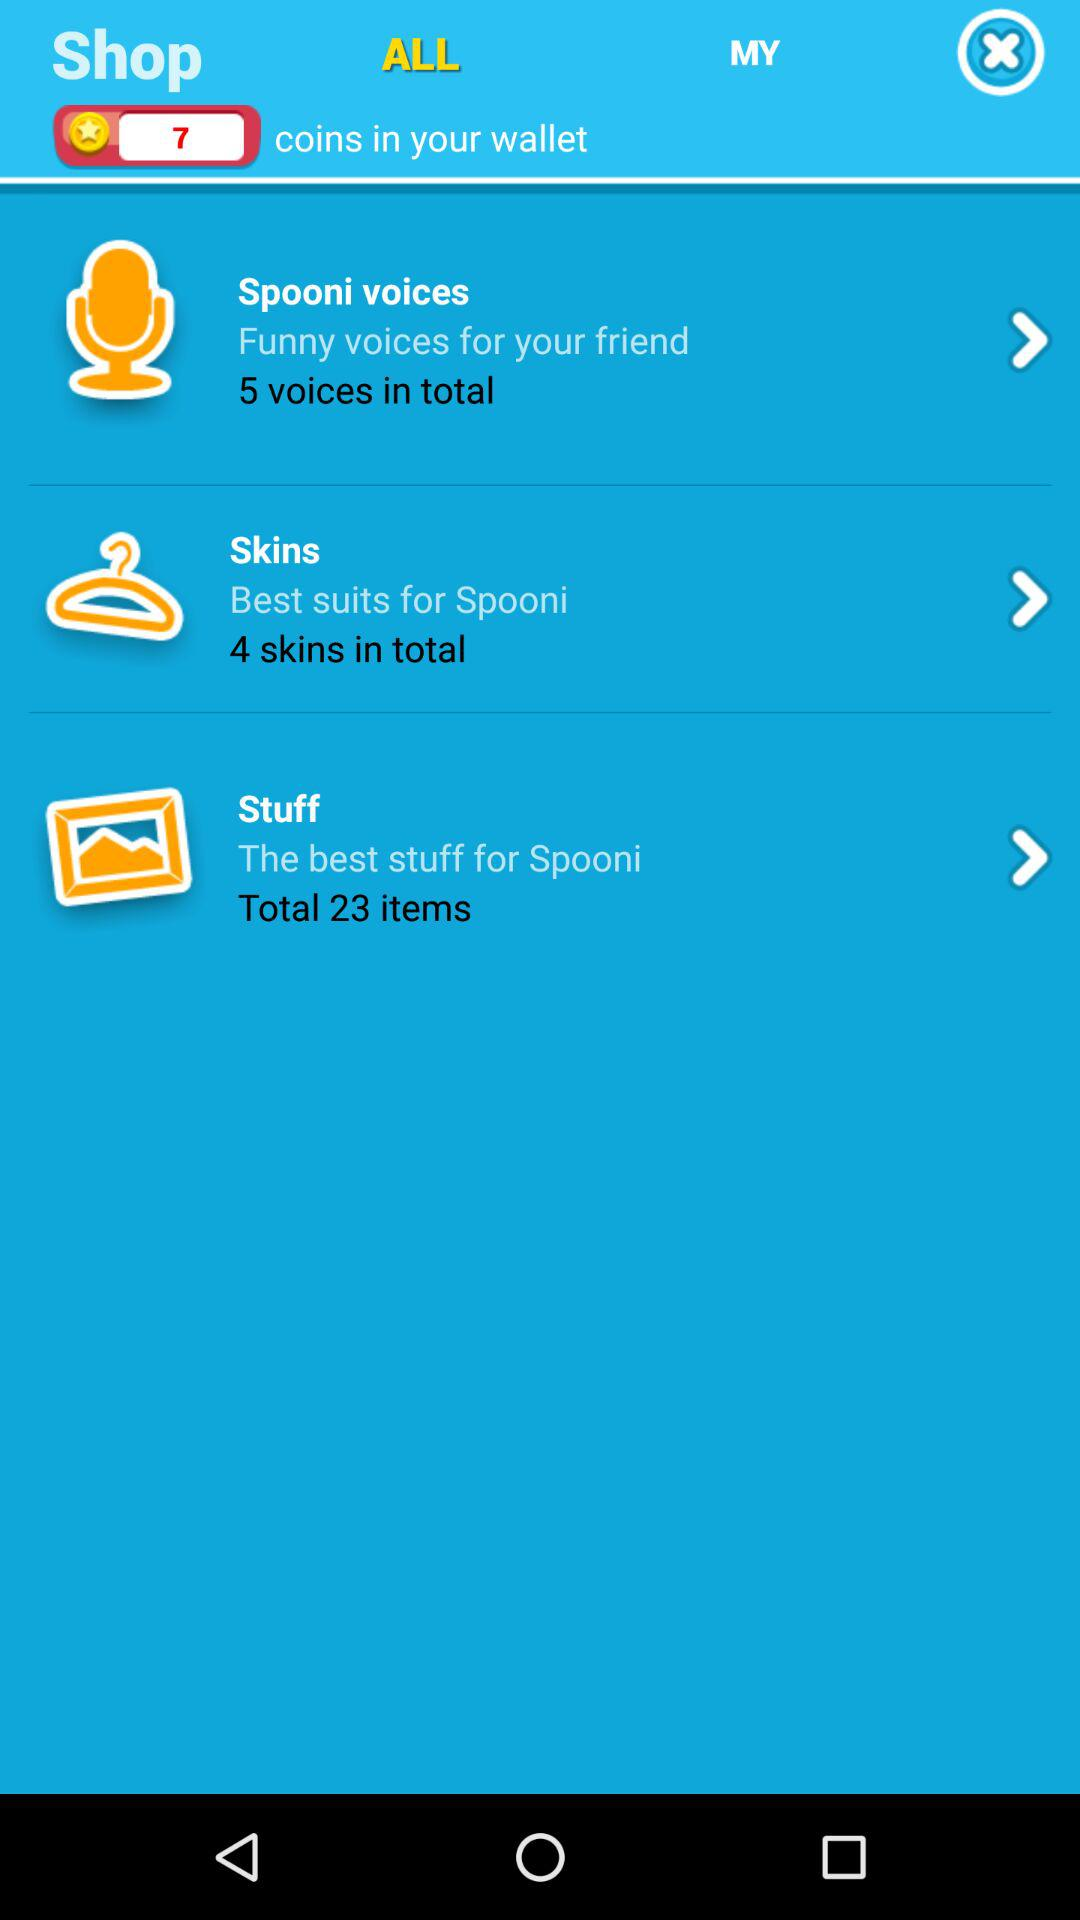What is the total number of skins included? There are 4 skins. 